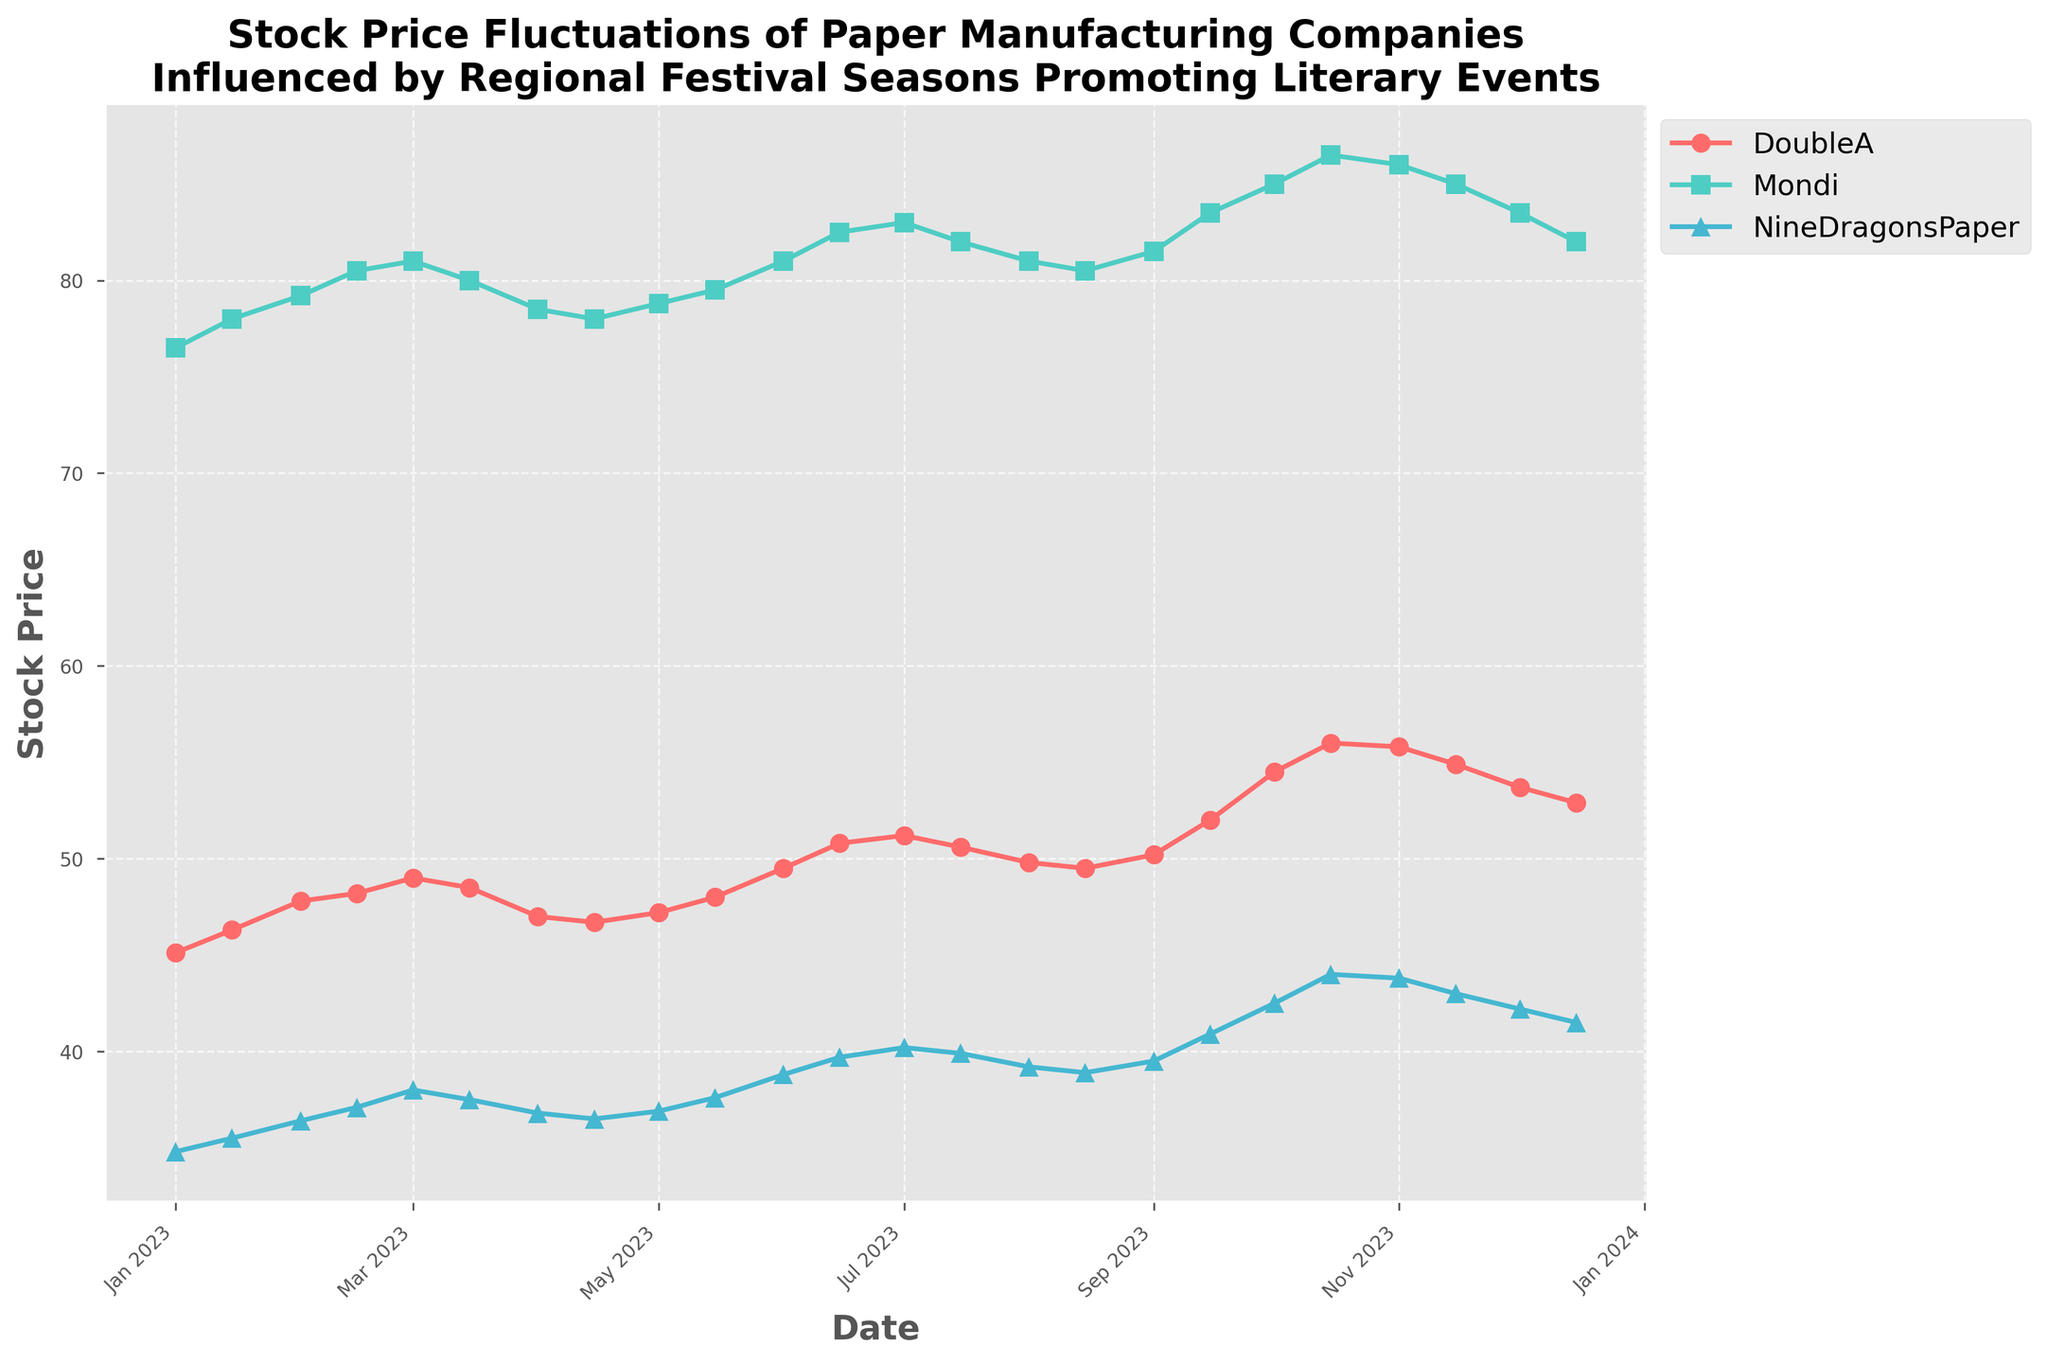What's the title of the plot? The title of the plot is displayed prominently at the top of the figure.
Answer: Stock Price Fluctuations of Paper Manufacturing Companies Influenced by Regional Festival Seasons Promoting Literary Events How does the stock price of DoubleA on January 1, 2023, compare to its price on December 15, 2023? Locate the stock price for DoubleA on both dates from the figure. On January 1, it is approximately $45.12, and on December 15, it is around $52.90.
Answer: The stock price increased Which company had the highest stock price at the peak value in October 2023? Look for the highest point in October 2023. DoubleA had a peak of $56.00 on October 15, which is higher than Mondi's $86.50 and Nine Dragons Paper's $44.00.
Answer: DoubleA What is the average stock price of Mondi in the first quarter of 2023? The first quarter comprises January, February, and March. Sum the stock prices of Mondi on January 1 (76.50), January 15 (78.00), February 1 (79.20), and February 15 (80.50), March 1 (81.00), and March 15 (80.00), and divide by the number of data points (6).
Answer: 79.20 On which date did Nine Dragons Paper experience its highest stock price? Observing the vertical peaks in the line plot for Nine Dragons Paper (blue line), the highest price was on October 15, 2023, at $44.00.
Answer: October 15, 2023 Compare the trends of stock prices for DoubleA and Mondi. Which company showed more volatility over the year? Examine the ups and downs of the stock price lines for both companies. DoubleA's prices varied more significantly, going from $45.12 to $56.00 and then down to $52.90. Mondi's changes were more gradual.
Answer: DoubleA What was the difference in stock prices of Mondi between the first and last data points in the plot? Subtract the stock price of Mondi on January 1 (76.50) from the stock price on December 15 (82.00).
Answer: 5.50 Which company showed the least fluctuation in its stock price throughout the year? By looking at the plot, the least fluctuating line is for Nine Dragons Paper, which shows the smallest price range changes compared to DoubleA and Mondi.
Answer: Nine Dragons Paper Considering Mid-Year and Year-End Stock Prices, did DoubleA show a growth, decline, or stagnation? Compare the price on July 1 (51.20) with the price on December 15 (52.90). It shows a minor growth.
Answer: Growth 